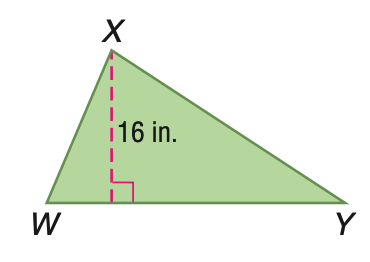Answer the mathemtical geometry problem and directly provide the correct option letter.
Question: Triangle W X Y has an area of 248 square inches. Find the length of the base.
Choices: A: 15.5 B: 16 C: 31 D: 32 C 